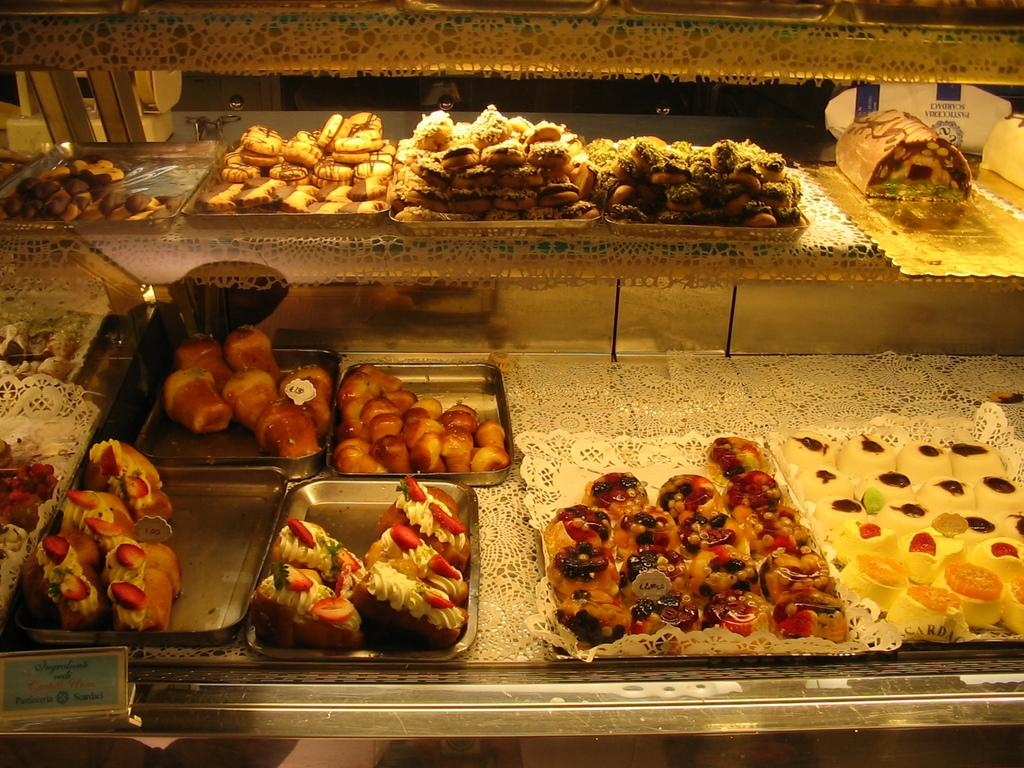What objects are on the desk in the image? There are trays on the desk in the image. What is inside the trays? There are food items in the trays. Can you describe the colors of the food items? The food items have colors: cream, brown, white, and red. Where is the sheep located in the image? There is no sheep present in the image. What type of meeting is taking place in the image? There is no meeting depicted in the image. 